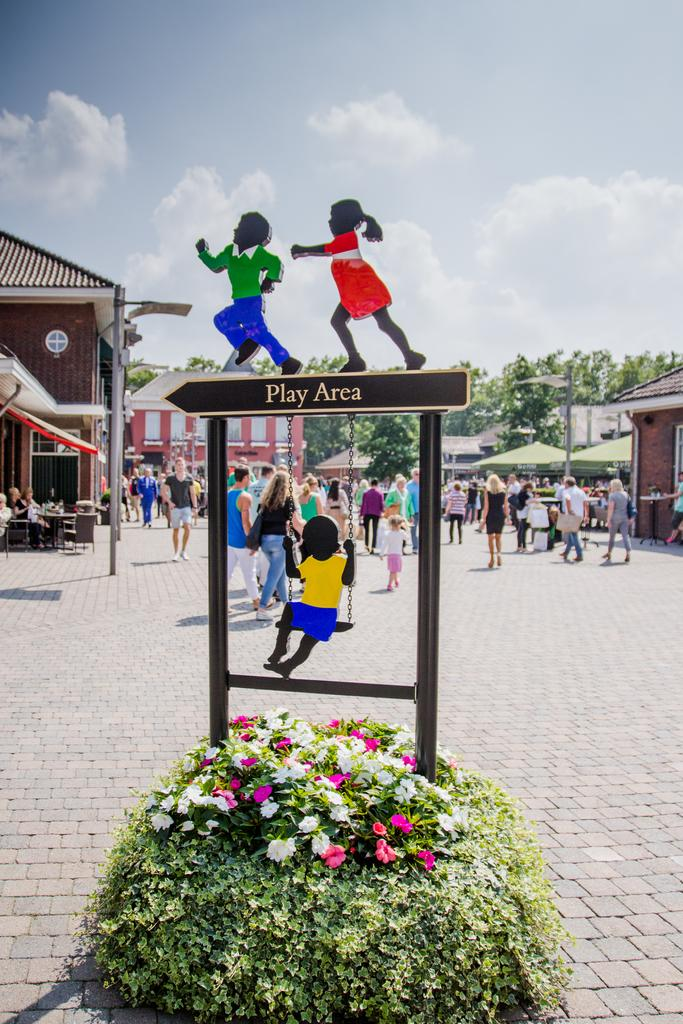What type of flora can be seen in the image? There are flowers and plants in the image. What is on the board in the image? The board has children's images in the image. What are the people in the image doing? There are people walking on the road in the image. What type of structures are visible in the image? There are houses in the image. What else can be seen in the image besides the flora and structures? There are trees in the image. What is visible in the background of the image? The sky with clouds is visible in the background of the image. What type of patch is being used to expand the cent in the image? There is no patch or cent present in the image. 